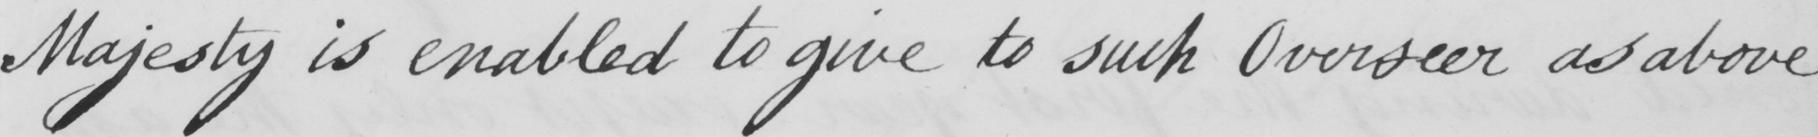What text is written in this handwritten line? Majesty is enabled to give to such Overseer as above- 